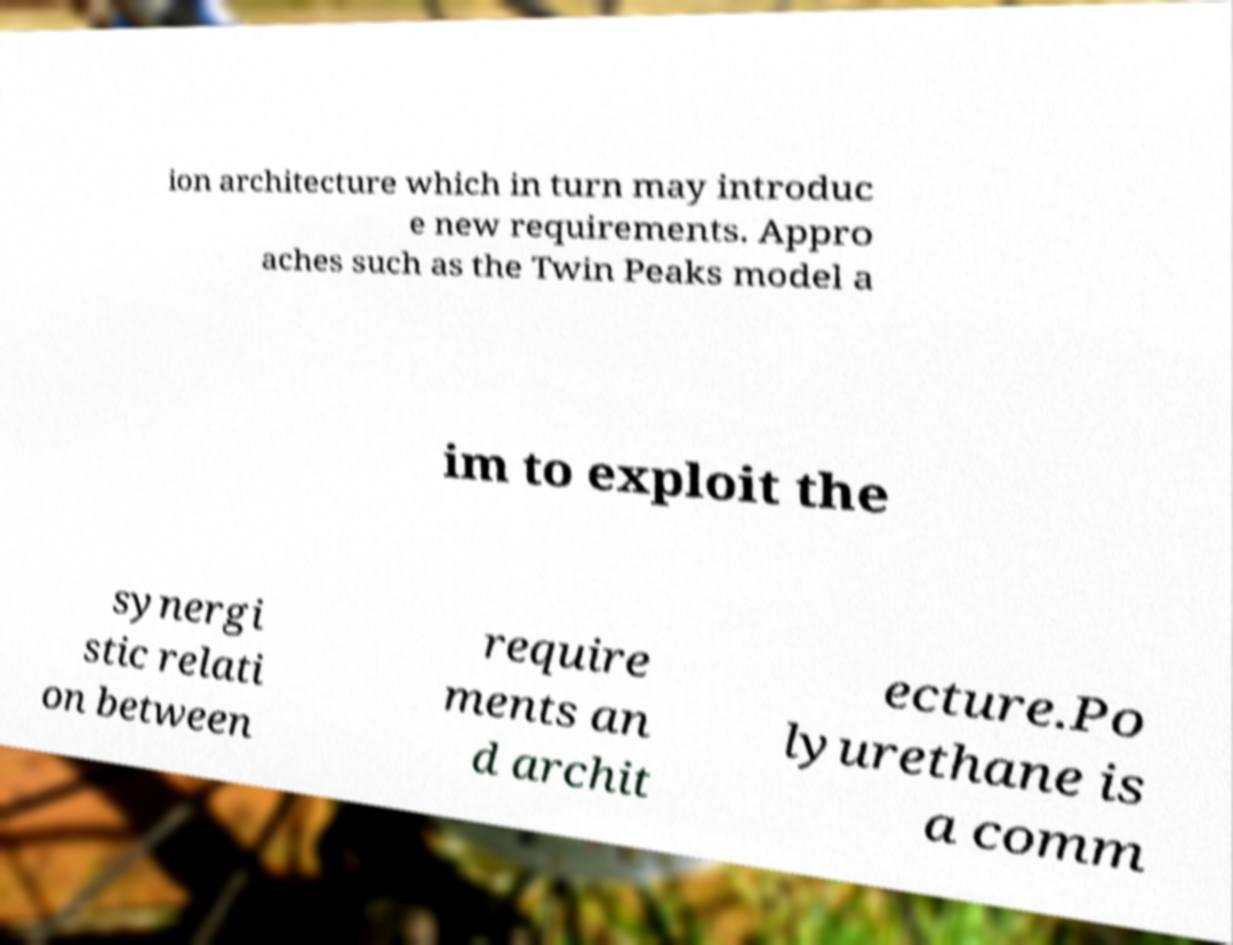Could you assist in decoding the text presented in this image and type it out clearly? ion architecture which in turn may introduc e new requirements. Appro aches such as the Twin Peaks model a im to exploit the synergi stic relati on between require ments an d archit ecture.Po lyurethane is a comm 